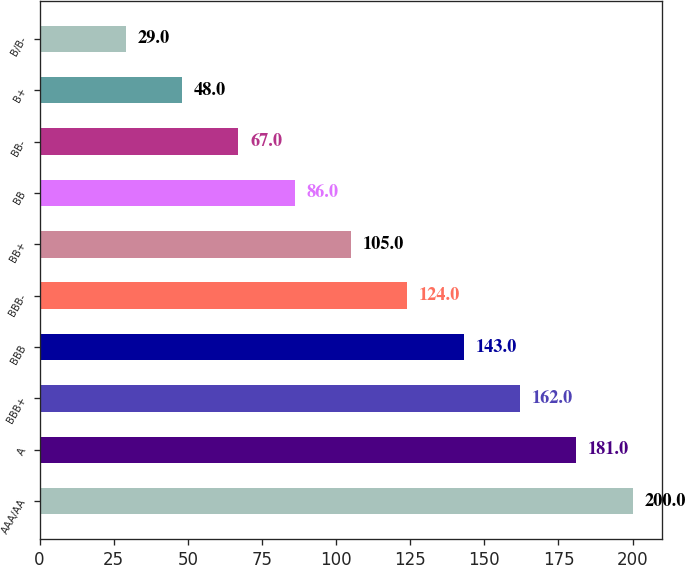Convert chart. <chart><loc_0><loc_0><loc_500><loc_500><bar_chart><fcel>AAA/AA<fcel>A<fcel>BBB+<fcel>BBB<fcel>BBB-<fcel>BB+<fcel>BB<fcel>BB-<fcel>B+<fcel>B/B-<nl><fcel>200<fcel>181<fcel>162<fcel>143<fcel>124<fcel>105<fcel>86<fcel>67<fcel>48<fcel>29<nl></chart> 